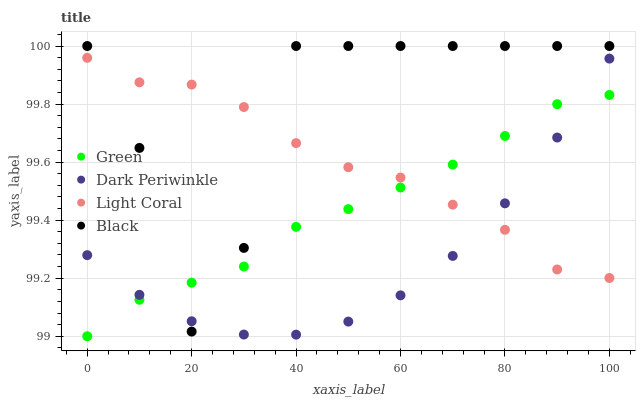Does Dark Periwinkle have the minimum area under the curve?
Answer yes or no. Yes. Does Black have the maximum area under the curve?
Answer yes or no. Yes. Does Green have the minimum area under the curve?
Answer yes or no. No. Does Green have the maximum area under the curve?
Answer yes or no. No. Is Green the smoothest?
Answer yes or no. Yes. Is Black the roughest?
Answer yes or no. Yes. Is Black the smoothest?
Answer yes or no. No. Is Green the roughest?
Answer yes or no. No. Does Green have the lowest value?
Answer yes or no. Yes. Does Black have the lowest value?
Answer yes or no. No. Does Black have the highest value?
Answer yes or no. Yes. Does Green have the highest value?
Answer yes or no. No. Does Green intersect Dark Periwinkle?
Answer yes or no. Yes. Is Green less than Dark Periwinkle?
Answer yes or no. No. Is Green greater than Dark Periwinkle?
Answer yes or no. No. 